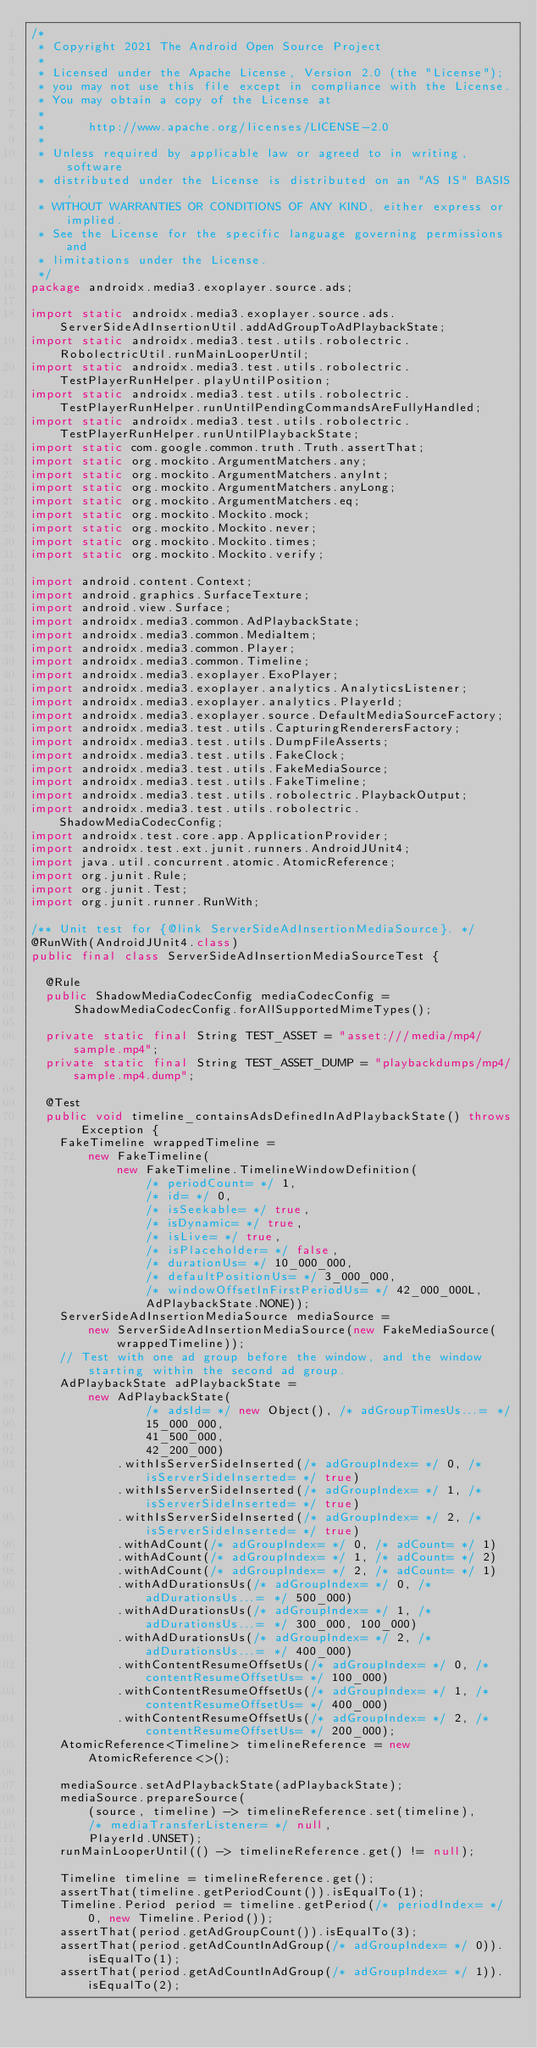<code> <loc_0><loc_0><loc_500><loc_500><_Java_>/*
 * Copyright 2021 The Android Open Source Project
 *
 * Licensed under the Apache License, Version 2.0 (the "License");
 * you may not use this file except in compliance with the License.
 * You may obtain a copy of the License at
 *
 *      http://www.apache.org/licenses/LICENSE-2.0
 *
 * Unless required by applicable law or agreed to in writing, software
 * distributed under the License is distributed on an "AS IS" BASIS,
 * WITHOUT WARRANTIES OR CONDITIONS OF ANY KIND, either express or implied.
 * See the License for the specific language governing permissions and
 * limitations under the License.
 */
package androidx.media3.exoplayer.source.ads;

import static androidx.media3.exoplayer.source.ads.ServerSideAdInsertionUtil.addAdGroupToAdPlaybackState;
import static androidx.media3.test.utils.robolectric.RobolectricUtil.runMainLooperUntil;
import static androidx.media3.test.utils.robolectric.TestPlayerRunHelper.playUntilPosition;
import static androidx.media3.test.utils.robolectric.TestPlayerRunHelper.runUntilPendingCommandsAreFullyHandled;
import static androidx.media3.test.utils.robolectric.TestPlayerRunHelper.runUntilPlaybackState;
import static com.google.common.truth.Truth.assertThat;
import static org.mockito.ArgumentMatchers.any;
import static org.mockito.ArgumentMatchers.anyInt;
import static org.mockito.ArgumentMatchers.anyLong;
import static org.mockito.ArgumentMatchers.eq;
import static org.mockito.Mockito.mock;
import static org.mockito.Mockito.never;
import static org.mockito.Mockito.times;
import static org.mockito.Mockito.verify;

import android.content.Context;
import android.graphics.SurfaceTexture;
import android.view.Surface;
import androidx.media3.common.AdPlaybackState;
import androidx.media3.common.MediaItem;
import androidx.media3.common.Player;
import androidx.media3.common.Timeline;
import androidx.media3.exoplayer.ExoPlayer;
import androidx.media3.exoplayer.analytics.AnalyticsListener;
import androidx.media3.exoplayer.analytics.PlayerId;
import androidx.media3.exoplayer.source.DefaultMediaSourceFactory;
import androidx.media3.test.utils.CapturingRenderersFactory;
import androidx.media3.test.utils.DumpFileAsserts;
import androidx.media3.test.utils.FakeClock;
import androidx.media3.test.utils.FakeMediaSource;
import androidx.media3.test.utils.FakeTimeline;
import androidx.media3.test.utils.robolectric.PlaybackOutput;
import androidx.media3.test.utils.robolectric.ShadowMediaCodecConfig;
import androidx.test.core.app.ApplicationProvider;
import androidx.test.ext.junit.runners.AndroidJUnit4;
import java.util.concurrent.atomic.AtomicReference;
import org.junit.Rule;
import org.junit.Test;
import org.junit.runner.RunWith;

/** Unit test for {@link ServerSideAdInsertionMediaSource}. */
@RunWith(AndroidJUnit4.class)
public final class ServerSideAdInsertionMediaSourceTest {

  @Rule
  public ShadowMediaCodecConfig mediaCodecConfig =
      ShadowMediaCodecConfig.forAllSupportedMimeTypes();

  private static final String TEST_ASSET = "asset:///media/mp4/sample.mp4";
  private static final String TEST_ASSET_DUMP = "playbackdumps/mp4/sample.mp4.dump";

  @Test
  public void timeline_containsAdsDefinedInAdPlaybackState() throws Exception {
    FakeTimeline wrappedTimeline =
        new FakeTimeline(
            new FakeTimeline.TimelineWindowDefinition(
                /* periodCount= */ 1,
                /* id= */ 0,
                /* isSeekable= */ true,
                /* isDynamic= */ true,
                /* isLive= */ true,
                /* isPlaceholder= */ false,
                /* durationUs= */ 10_000_000,
                /* defaultPositionUs= */ 3_000_000,
                /* windowOffsetInFirstPeriodUs= */ 42_000_000L,
                AdPlaybackState.NONE));
    ServerSideAdInsertionMediaSource mediaSource =
        new ServerSideAdInsertionMediaSource(new FakeMediaSource(wrappedTimeline));
    // Test with one ad group before the window, and the window starting within the second ad group.
    AdPlaybackState adPlaybackState =
        new AdPlaybackState(
                /* adsId= */ new Object(), /* adGroupTimesUs...= */
                15_000_000,
                41_500_000,
                42_200_000)
            .withIsServerSideInserted(/* adGroupIndex= */ 0, /* isServerSideInserted= */ true)
            .withIsServerSideInserted(/* adGroupIndex= */ 1, /* isServerSideInserted= */ true)
            .withIsServerSideInserted(/* adGroupIndex= */ 2, /* isServerSideInserted= */ true)
            .withAdCount(/* adGroupIndex= */ 0, /* adCount= */ 1)
            .withAdCount(/* adGroupIndex= */ 1, /* adCount= */ 2)
            .withAdCount(/* adGroupIndex= */ 2, /* adCount= */ 1)
            .withAdDurationsUs(/* adGroupIndex= */ 0, /* adDurationsUs...= */ 500_000)
            .withAdDurationsUs(/* adGroupIndex= */ 1, /* adDurationsUs...= */ 300_000, 100_000)
            .withAdDurationsUs(/* adGroupIndex= */ 2, /* adDurationsUs...= */ 400_000)
            .withContentResumeOffsetUs(/* adGroupIndex= */ 0, /* contentResumeOffsetUs= */ 100_000)
            .withContentResumeOffsetUs(/* adGroupIndex= */ 1, /* contentResumeOffsetUs= */ 400_000)
            .withContentResumeOffsetUs(/* adGroupIndex= */ 2, /* contentResumeOffsetUs= */ 200_000);
    AtomicReference<Timeline> timelineReference = new AtomicReference<>();

    mediaSource.setAdPlaybackState(adPlaybackState);
    mediaSource.prepareSource(
        (source, timeline) -> timelineReference.set(timeline),
        /* mediaTransferListener= */ null,
        PlayerId.UNSET);
    runMainLooperUntil(() -> timelineReference.get() != null);

    Timeline timeline = timelineReference.get();
    assertThat(timeline.getPeriodCount()).isEqualTo(1);
    Timeline.Period period = timeline.getPeriod(/* periodIndex= */ 0, new Timeline.Period());
    assertThat(period.getAdGroupCount()).isEqualTo(3);
    assertThat(period.getAdCountInAdGroup(/* adGroupIndex= */ 0)).isEqualTo(1);
    assertThat(period.getAdCountInAdGroup(/* adGroupIndex= */ 1)).isEqualTo(2);</code> 